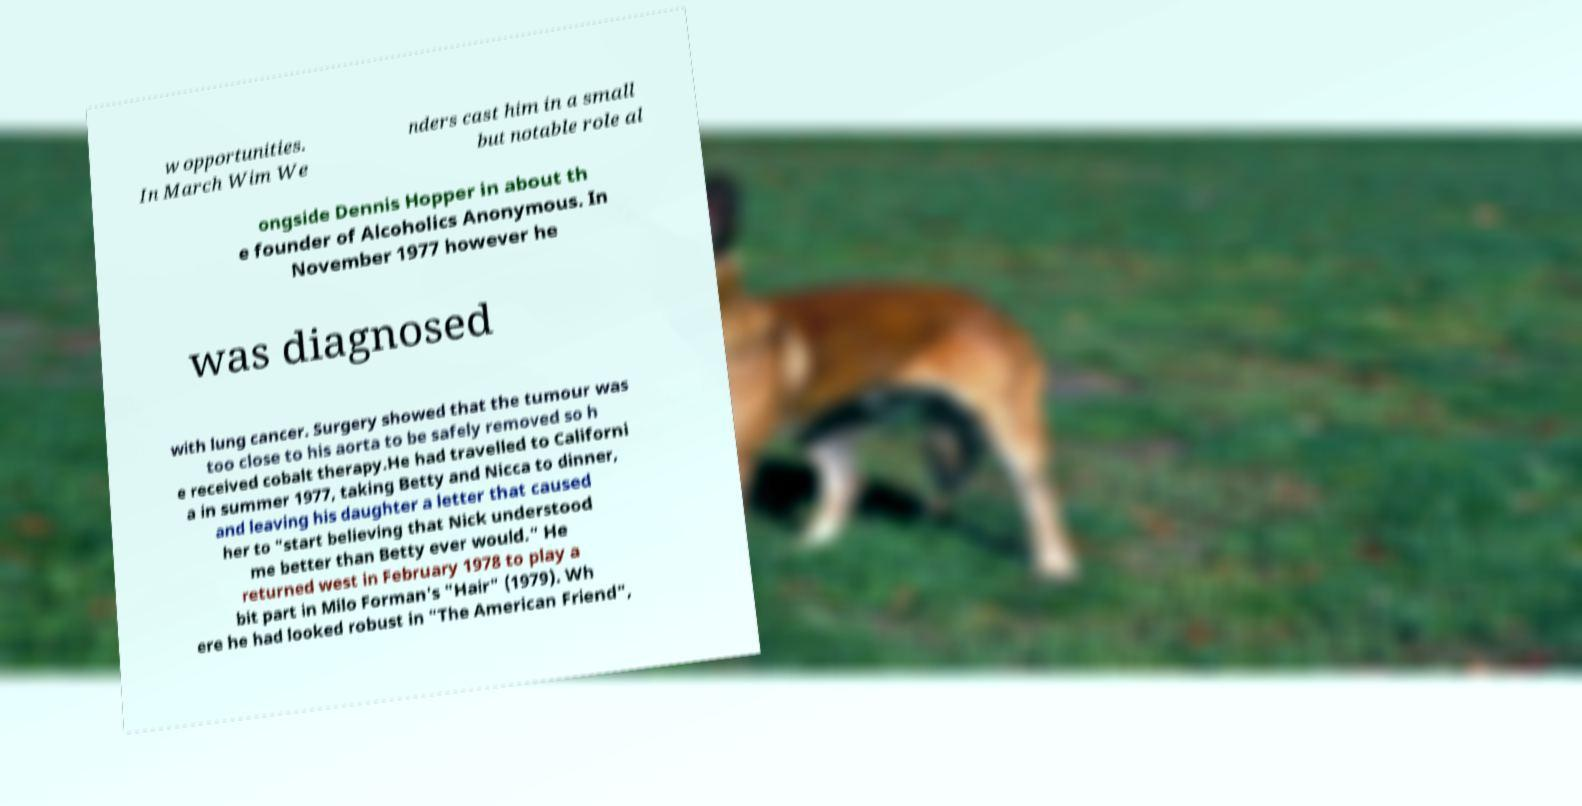Could you extract and type out the text from this image? w opportunities. In March Wim We nders cast him in a small but notable role al ongside Dennis Hopper in about th e founder of Alcoholics Anonymous. In November 1977 however he was diagnosed with lung cancer. Surgery showed that the tumour was too close to his aorta to be safely removed so h e received cobalt therapy.He had travelled to Californi a in summer 1977, taking Betty and Nicca to dinner, and leaving his daughter a letter that caused her to "start believing that Nick understood me better than Betty ever would." He returned west in February 1978 to play a bit part in Milo Forman's "Hair" (1979). Wh ere he had looked robust in "The American Friend", 